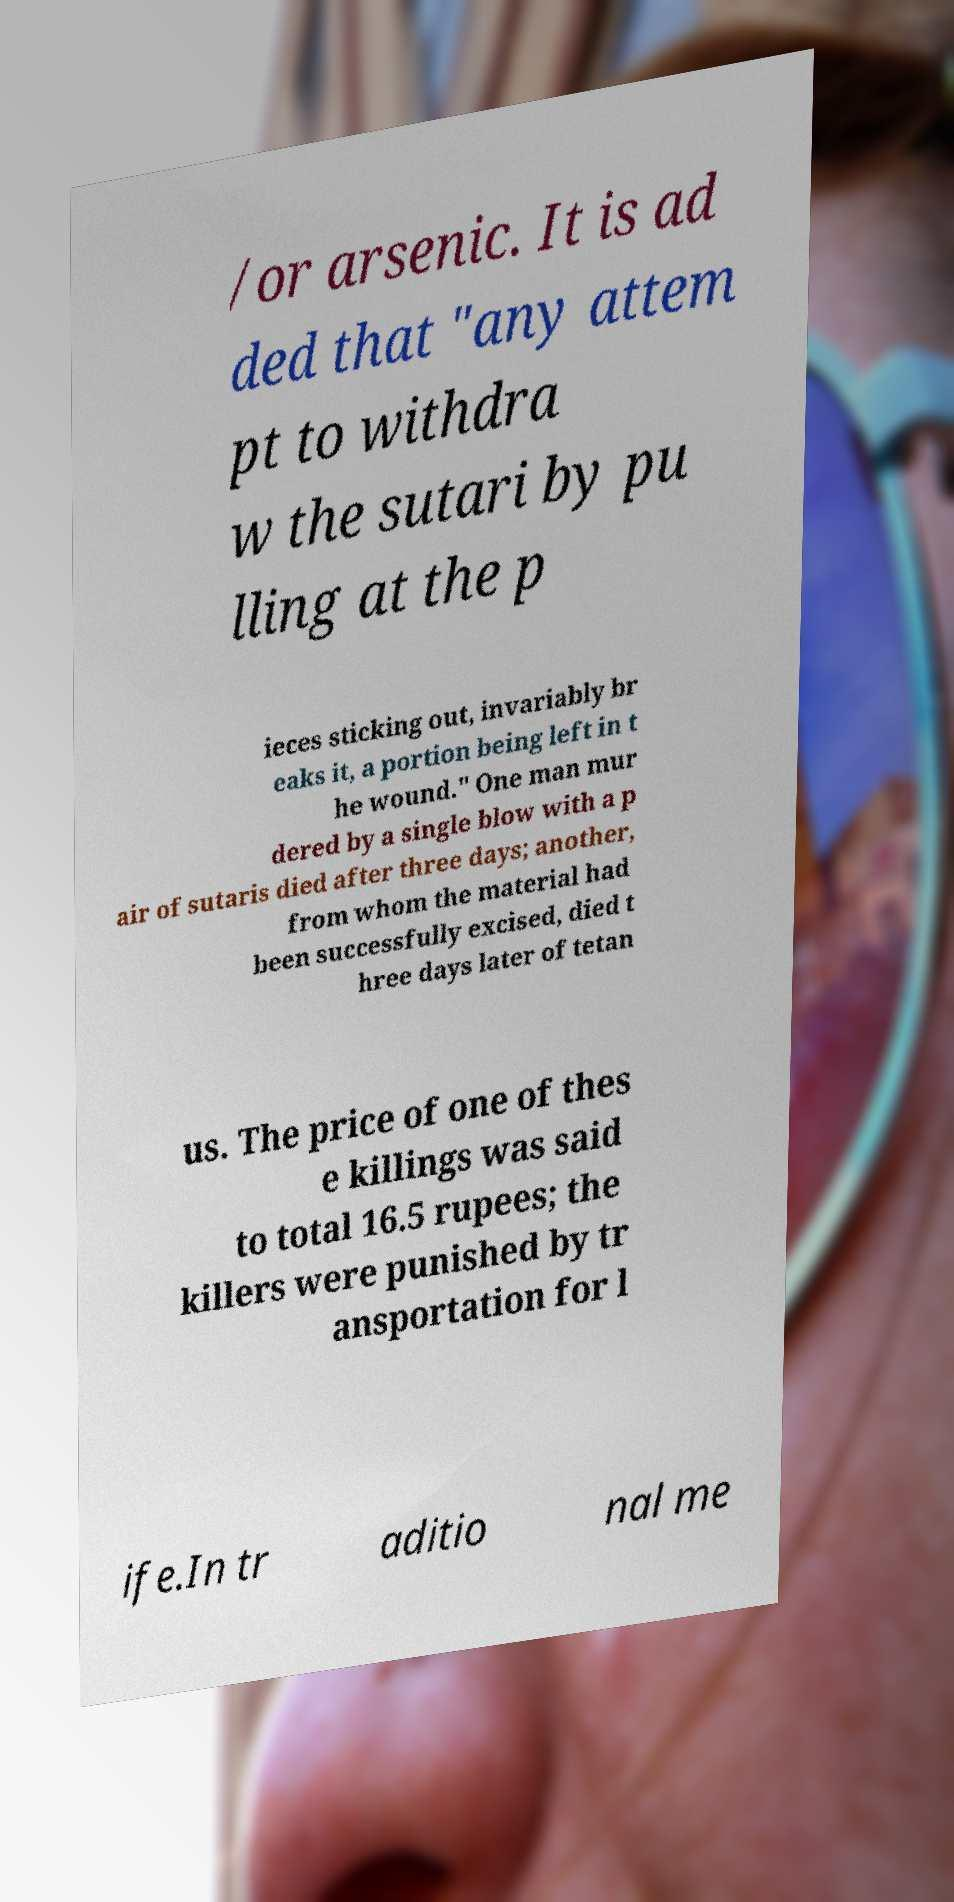Could you extract and type out the text from this image? /or arsenic. It is ad ded that "any attem pt to withdra w the sutari by pu lling at the p ieces sticking out, invariably br eaks it, a portion being left in t he wound." One man mur dered by a single blow with a p air of sutaris died after three days; another, from whom the material had been successfully excised, died t hree days later of tetan us. The price of one of thes e killings was said to total 16.5 rupees; the killers were punished by tr ansportation for l ife.In tr aditio nal me 